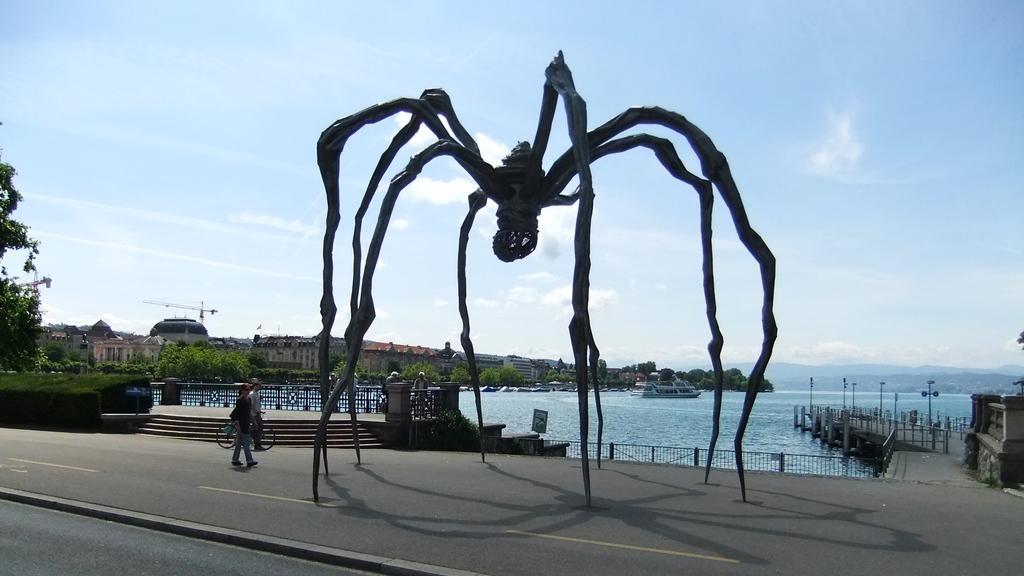In one or two sentences, can you explain what this image depicts? Here in this picture we can see a big spider like thing present on the ground over there and beside it we can see people walking on the road over there and we can see trees and plants present here and there and we can also see buildings in the far and we can see a river behind it, as we can see water present all over there and we can see railing present around it and we can see some poles present here and there and we can also see clouds in the sky. 